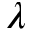Convert formula to latex. <formula><loc_0><loc_0><loc_500><loc_500>\lambda</formula> 